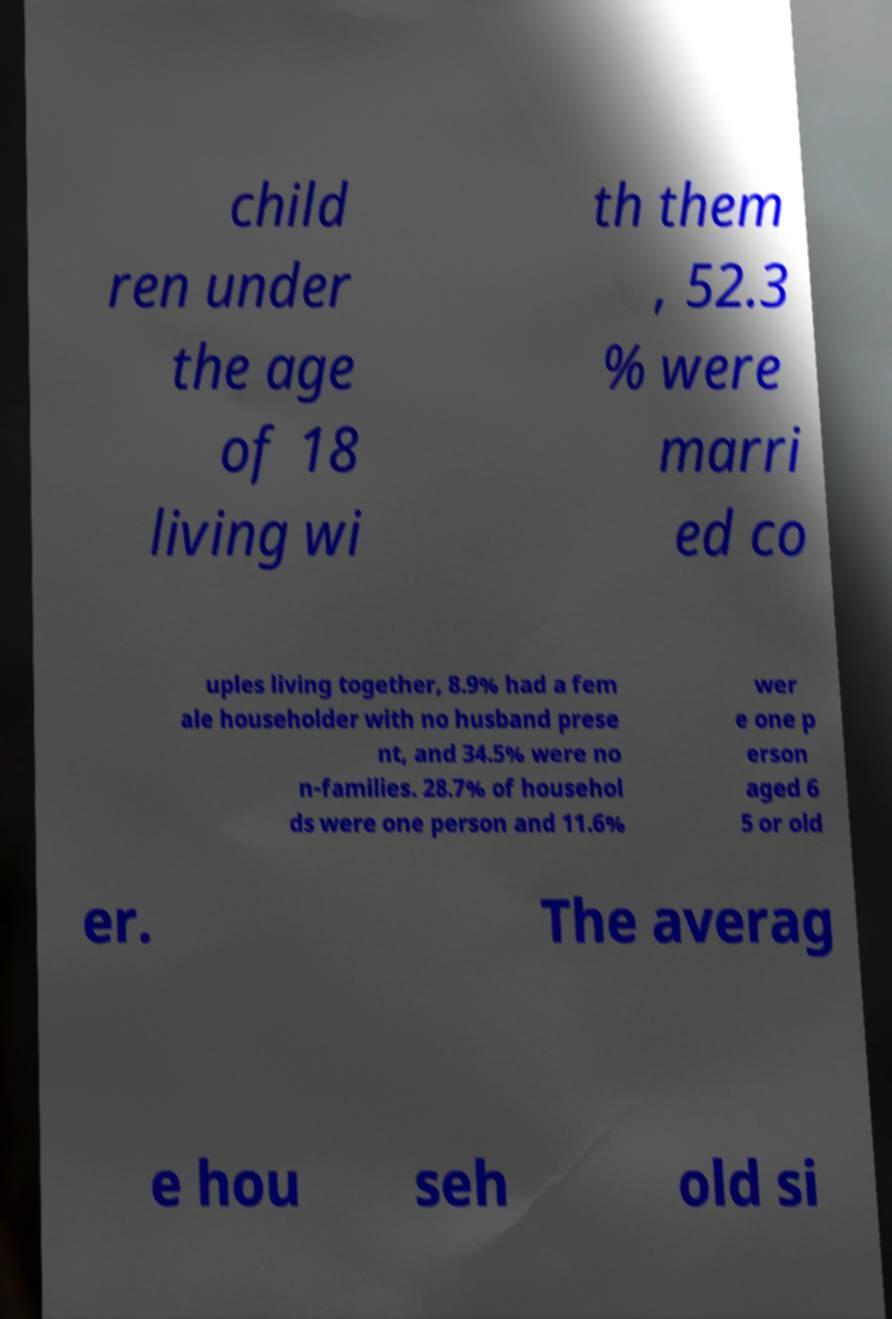Could you extract and type out the text from this image? child ren under the age of 18 living wi th them , 52.3 % were marri ed co uples living together, 8.9% had a fem ale householder with no husband prese nt, and 34.5% were no n-families. 28.7% of househol ds were one person and 11.6% wer e one p erson aged 6 5 or old er. The averag e hou seh old si 